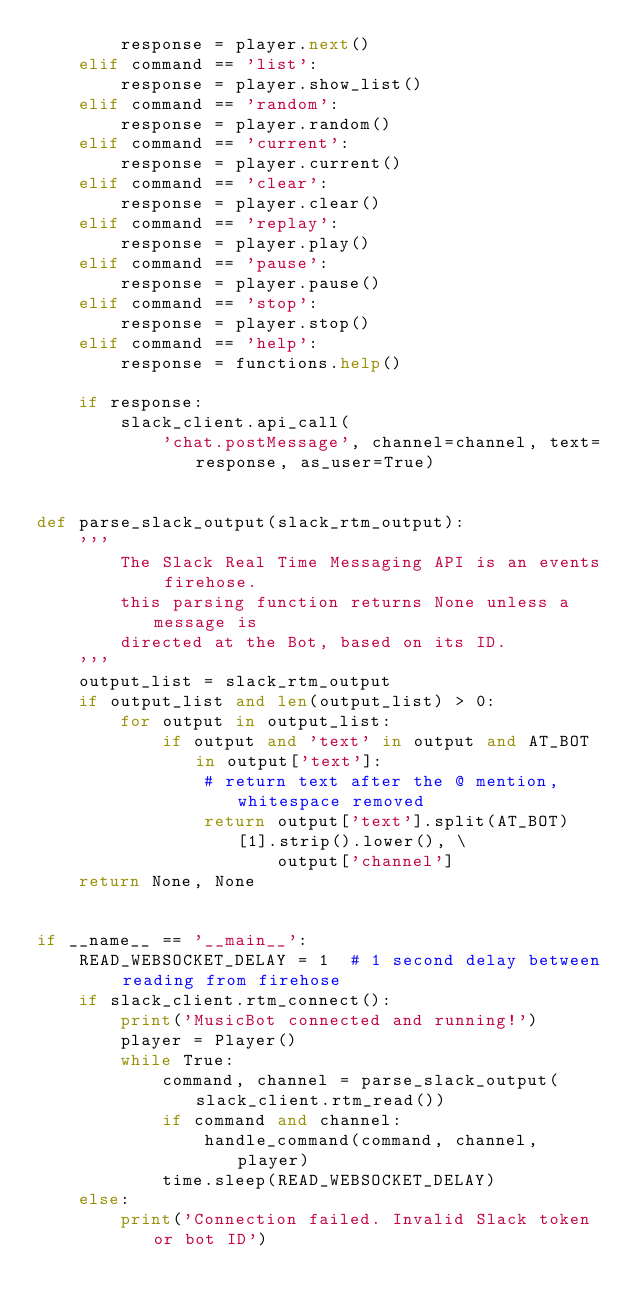<code> <loc_0><loc_0><loc_500><loc_500><_Python_>        response = player.next()
    elif command == 'list':
        response = player.show_list()
    elif command == 'random':
        response = player.random()
    elif command == 'current':
        response = player.current()
    elif command == 'clear':
        response = player.clear()
    elif command == 'replay':
        response = player.play()
    elif command == 'pause':
        response = player.pause()
    elif command == 'stop':
        response = player.stop()
    elif command == 'help':
        response = functions.help()

    if response:
        slack_client.api_call(
            'chat.postMessage', channel=channel, text=response, as_user=True)


def parse_slack_output(slack_rtm_output):
    '''
        The Slack Real Time Messaging API is an events firehose.
        this parsing function returns None unless a message is
        directed at the Bot, based on its ID.
    '''
    output_list = slack_rtm_output
    if output_list and len(output_list) > 0:
        for output in output_list:
            if output and 'text' in output and AT_BOT in output['text']:
                # return text after the @ mention, whitespace removed
                return output['text'].split(AT_BOT)[1].strip().lower(), \
                       output['channel']
    return None, None


if __name__ == '__main__':
    READ_WEBSOCKET_DELAY = 1  # 1 second delay between reading from firehose
    if slack_client.rtm_connect():
        print('MusicBot connected and running!')
        player = Player()
        while True:
            command, channel = parse_slack_output(slack_client.rtm_read())
            if command and channel:
                handle_command(command, channel, player)
            time.sleep(READ_WEBSOCKET_DELAY)
    else:
        print('Connection failed. Invalid Slack token or bot ID')
</code> 